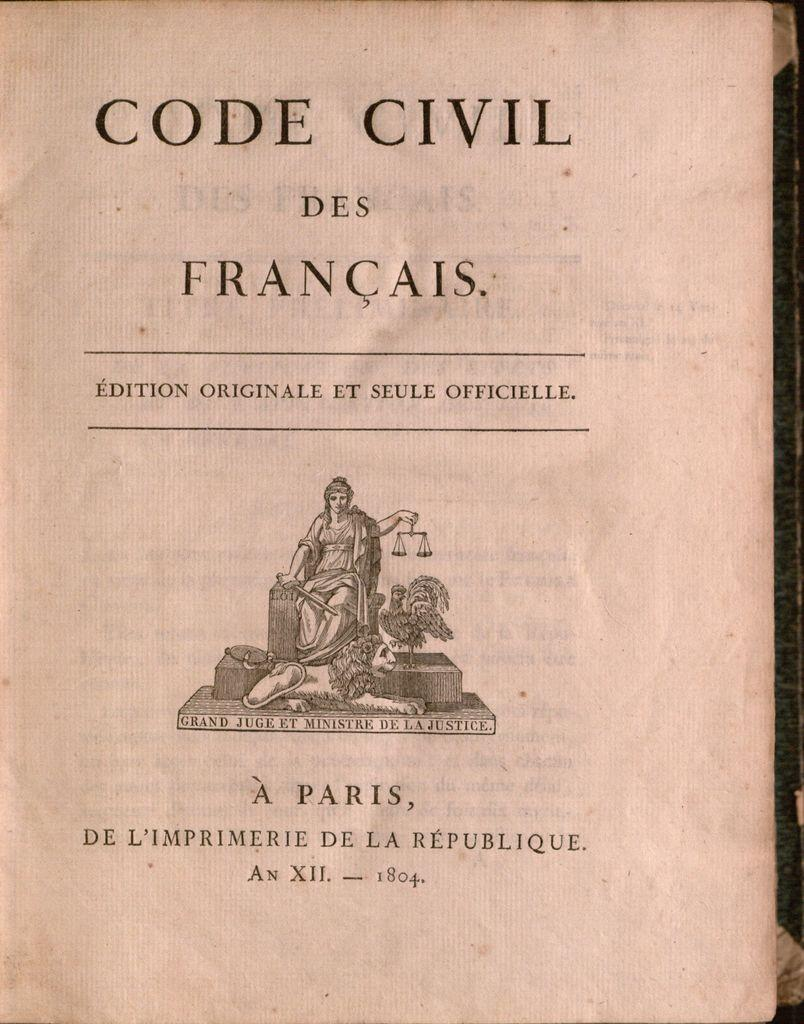Provide a one-sentence caption for the provided image. A book called Code Civil Des Francais by A Paris. 